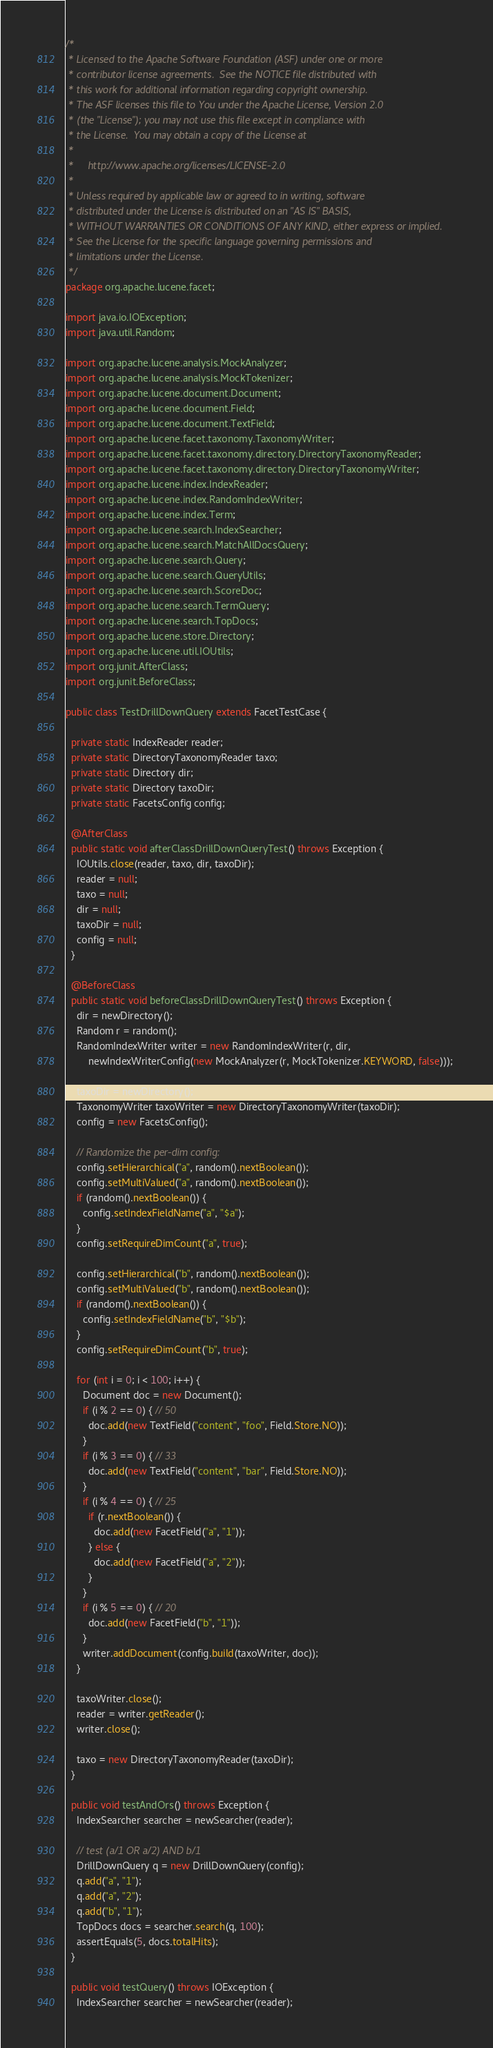<code> <loc_0><loc_0><loc_500><loc_500><_Java_>/*
 * Licensed to the Apache Software Foundation (ASF) under one or more
 * contributor license agreements.  See the NOTICE file distributed with
 * this work for additional information regarding copyright ownership.
 * The ASF licenses this file to You under the Apache License, Version 2.0
 * (the "License"); you may not use this file except in compliance with
 * the License.  You may obtain a copy of the License at
 *
 *     http://www.apache.org/licenses/LICENSE-2.0
 *
 * Unless required by applicable law or agreed to in writing, software
 * distributed under the License is distributed on an "AS IS" BASIS,
 * WITHOUT WARRANTIES OR CONDITIONS OF ANY KIND, either express or implied.
 * See the License for the specific language governing permissions and
 * limitations under the License.
 */
package org.apache.lucene.facet;

import java.io.IOException;
import java.util.Random;

import org.apache.lucene.analysis.MockAnalyzer;
import org.apache.lucene.analysis.MockTokenizer;
import org.apache.lucene.document.Document;
import org.apache.lucene.document.Field;
import org.apache.lucene.document.TextField;
import org.apache.lucene.facet.taxonomy.TaxonomyWriter;
import org.apache.lucene.facet.taxonomy.directory.DirectoryTaxonomyReader;
import org.apache.lucene.facet.taxonomy.directory.DirectoryTaxonomyWriter;
import org.apache.lucene.index.IndexReader;
import org.apache.lucene.index.RandomIndexWriter;
import org.apache.lucene.index.Term;
import org.apache.lucene.search.IndexSearcher;
import org.apache.lucene.search.MatchAllDocsQuery;
import org.apache.lucene.search.Query;
import org.apache.lucene.search.QueryUtils;
import org.apache.lucene.search.ScoreDoc;
import org.apache.lucene.search.TermQuery;
import org.apache.lucene.search.TopDocs;
import org.apache.lucene.store.Directory;
import org.apache.lucene.util.IOUtils;
import org.junit.AfterClass;
import org.junit.BeforeClass;

public class TestDrillDownQuery extends FacetTestCase {
  
  private static IndexReader reader;
  private static DirectoryTaxonomyReader taxo;
  private static Directory dir;
  private static Directory taxoDir;
  private static FacetsConfig config;

  @AfterClass
  public static void afterClassDrillDownQueryTest() throws Exception {
    IOUtils.close(reader, taxo, dir, taxoDir);
    reader = null;
    taxo = null;
    dir = null;
    taxoDir = null;
    config = null;
  }

  @BeforeClass
  public static void beforeClassDrillDownQueryTest() throws Exception {
    dir = newDirectory();
    Random r = random();
    RandomIndexWriter writer = new RandomIndexWriter(r, dir, 
        newIndexWriterConfig(new MockAnalyzer(r, MockTokenizer.KEYWORD, false)));
    
    taxoDir = newDirectory();
    TaxonomyWriter taxoWriter = new DirectoryTaxonomyWriter(taxoDir);
    config = new FacetsConfig();

    // Randomize the per-dim config:
    config.setHierarchical("a", random().nextBoolean());
    config.setMultiValued("a", random().nextBoolean());
    if (random().nextBoolean()) {
      config.setIndexFieldName("a", "$a");
    }
    config.setRequireDimCount("a", true);

    config.setHierarchical("b", random().nextBoolean());
    config.setMultiValued("b", random().nextBoolean());
    if (random().nextBoolean()) {
      config.setIndexFieldName("b", "$b");
    }
    config.setRequireDimCount("b", true);

    for (int i = 0; i < 100; i++) {
      Document doc = new Document();
      if (i % 2 == 0) { // 50
        doc.add(new TextField("content", "foo", Field.Store.NO));
      }
      if (i % 3 == 0) { // 33
        doc.add(new TextField("content", "bar", Field.Store.NO));
      }
      if (i % 4 == 0) { // 25
        if (r.nextBoolean()) {
          doc.add(new FacetField("a", "1"));
        } else {
          doc.add(new FacetField("a", "2"));
        }
      }
      if (i % 5 == 0) { // 20
        doc.add(new FacetField("b", "1"));
      }
      writer.addDocument(config.build(taxoWriter, doc));
    }
    
    taxoWriter.close();
    reader = writer.getReader();
    writer.close();
    
    taxo = new DirectoryTaxonomyReader(taxoDir);
  }
  
  public void testAndOrs() throws Exception {
    IndexSearcher searcher = newSearcher(reader);

    // test (a/1 OR a/2) AND b/1
    DrillDownQuery q = new DrillDownQuery(config);
    q.add("a", "1");
    q.add("a", "2");
    q.add("b", "1");
    TopDocs docs = searcher.search(q, 100);
    assertEquals(5, docs.totalHits);
  }
  
  public void testQuery() throws IOException {
    IndexSearcher searcher = newSearcher(reader);
</code> 